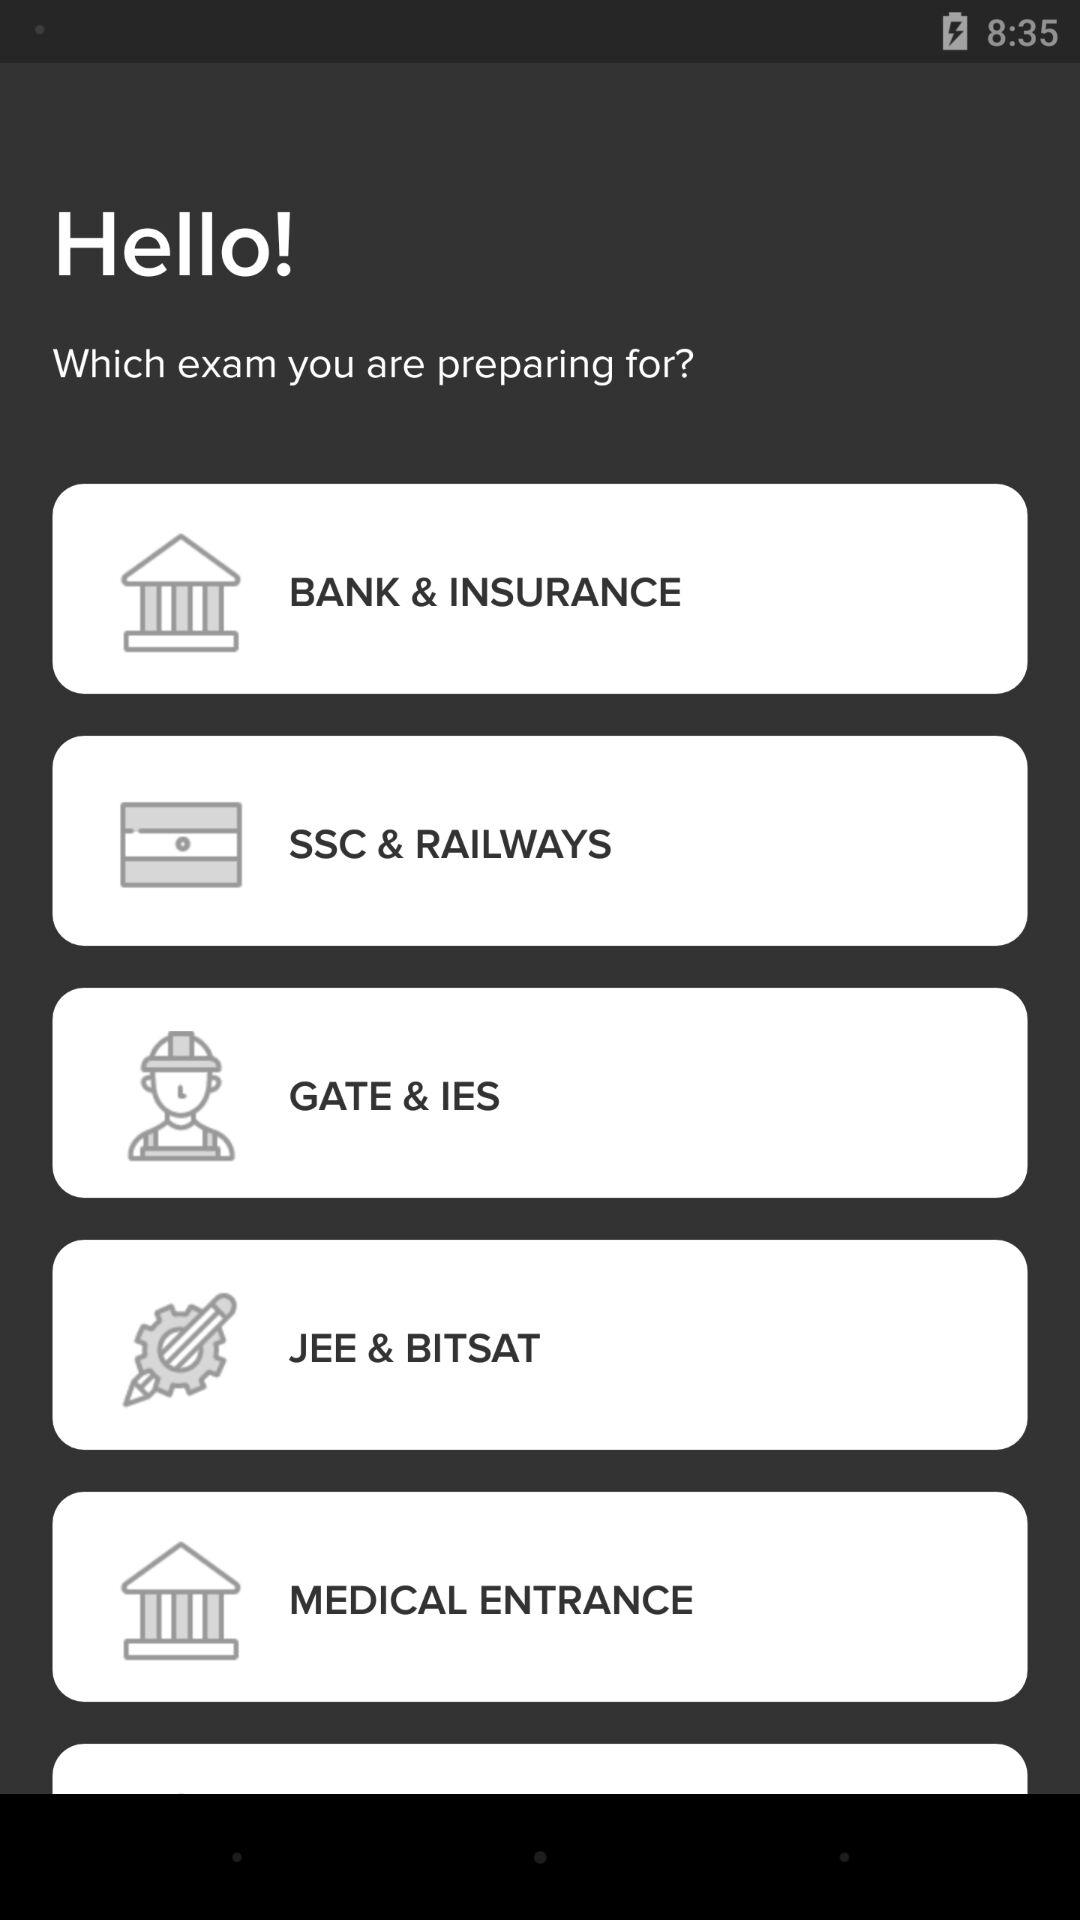What are the different exam categories that are available? The different exam categories are "BANK & INSURANCE", "SSC & RAILWAYS", "GATE & IES", "JEE & BITSAT" and "MEDICAL ENTRANCE". 